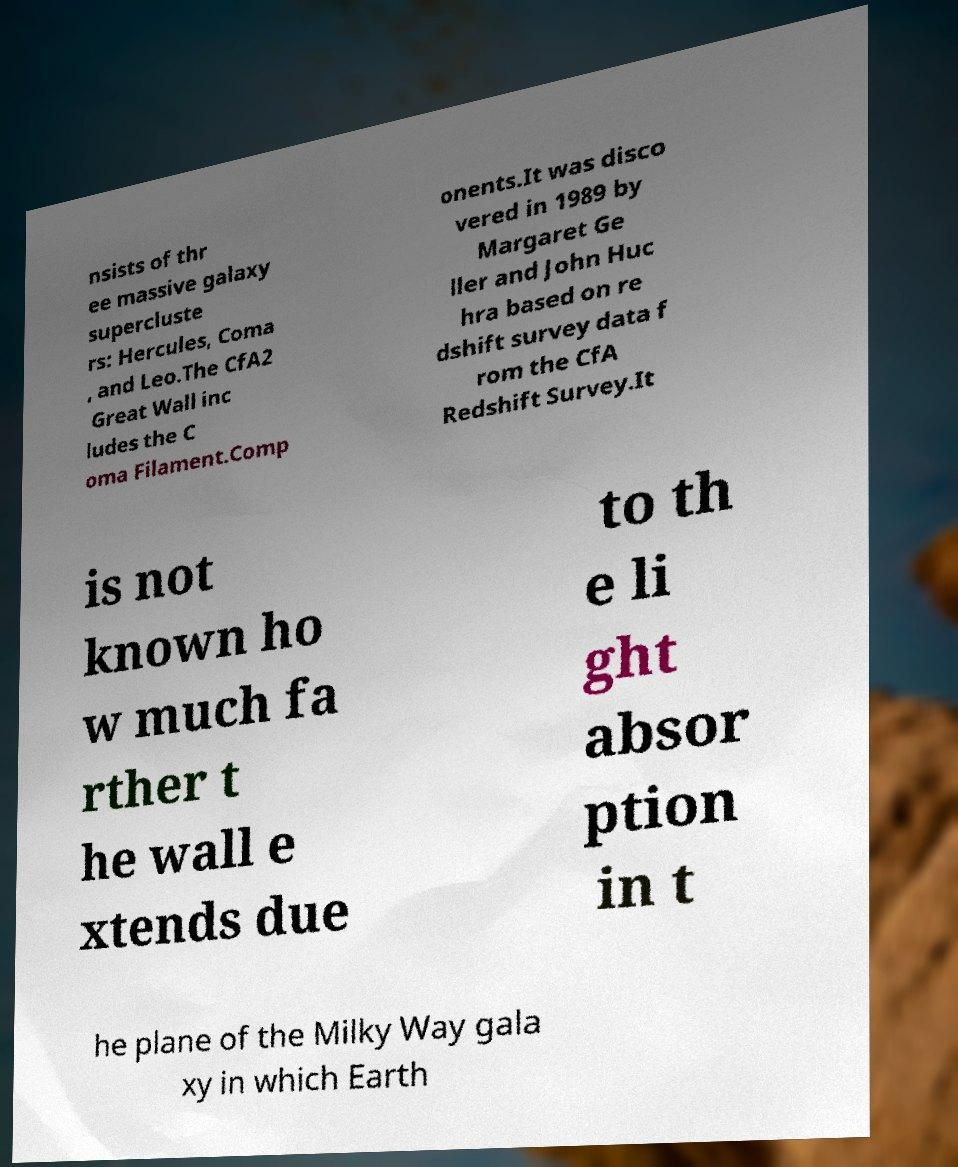What messages or text are displayed in this image? I need them in a readable, typed format. nsists of thr ee massive galaxy supercluste rs: Hercules, Coma , and Leo.The CfA2 Great Wall inc ludes the C oma Filament.Comp onents.It was disco vered in 1989 by Margaret Ge ller and John Huc hra based on re dshift survey data f rom the CfA Redshift Survey.It is not known ho w much fa rther t he wall e xtends due to th e li ght absor ption in t he plane of the Milky Way gala xy in which Earth 